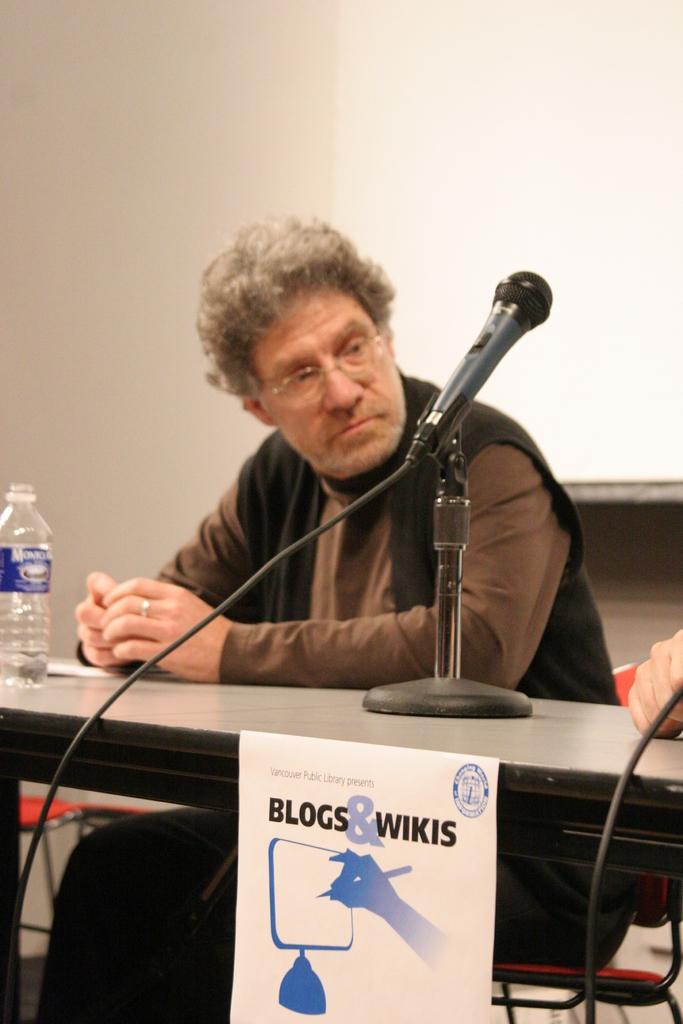Who is present in the image? There is a man in the image. What is the man doing in the image? The man is sitting. What object can be seen on the table in the image? There is a water bottle on the table. How many eggs are being sorted by the man in the image? There are no eggs present in the image, and the man is not sorting anything. 